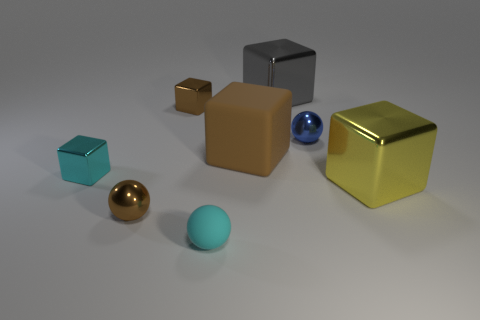Is there anything else of the same color as the rubber ball?
Offer a very short reply. Yes. The blue object that is made of the same material as the yellow cube is what shape?
Offer a terse response. Sphere. The small object that is to the right of the matte ball that is to the right of the small brown metallic ball is made of what material?
Keep it short and to the point. Metal. There is a tiny brown thing that is in front of the brown matte thing; does it have the same shape as the brown rubber object?
Provide a succinct answer. No. Are there more cyan matte things behind the gray shiny block than big purple rubber objects?
Make the answer very short. No. Is there any other thing that has the same material as the small blue object?
Make the answer very short. Yes. There is a small shiny object that is the same color as the small rubber ball; what shape is it?
Keep it short and to the point. Cube. What number of cylinders are big rubber objects or small blue metal objects?
Give a very brief answer. 0. There is a tiny shiny block in front of the small ball that is behind the brown metallic sphere; what color is it?
Provide a succinct answer. Cyan. Is the color of the matte cube the same as the tiny shiny sphere that is on the left side of the tiny blue shiny object?
Your answer should be compact. Yes. 